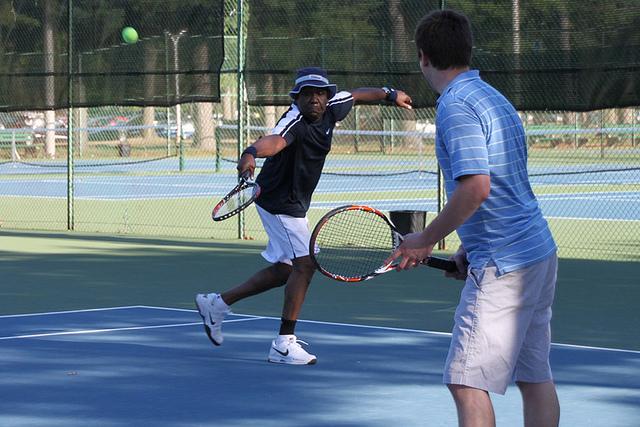Who just hit the ball?
Be succinct. Man. How many men in the picture?
Write a very short answer. 2. Where is the ball?
Give a very brief answer. Air. Is somebody taking pictures?
Quick response, please. Yes. What are the men holding?
Answer briefly. Rackets. What sport is this?
Give a very brief answer. Tennis. 